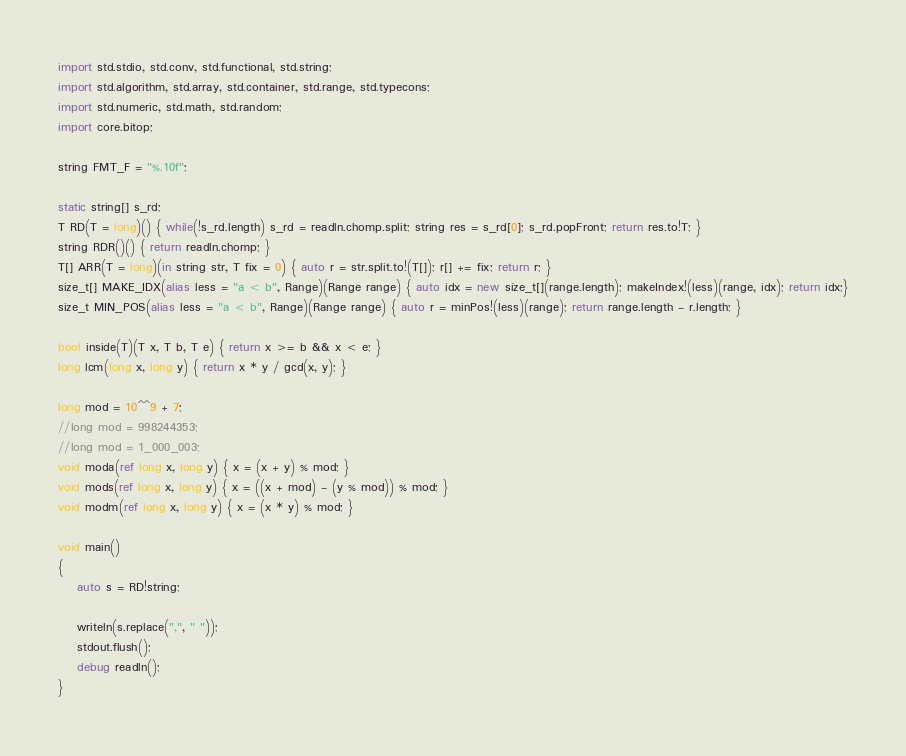<code> <loc_0><loc_0><loc_500><loc_500><_D_>import std.stdio, std.conv, std.functional, std.string;
import std.algorithm, std.array, std.container, std.range, std.typecons;
import std.numeric, std.math, std.random;
import core.bitop;

string FMT_F = "%.10f";

static string[] s_rd;
T RD(T = long)() { while(!s_rd.length) s_rd = readln.chomp.split; string res = s_rd[0]; s_rd.popFront; return res.to!T; }
string RDR()() { return readln.chomp; }
T[] ARR(T = long)(in string str, T fix = 0) { auto r = str.split.to!(T[]); r[] += fix; return r; }
size_t[] MAKE_IDX(alias less = "a < b", Range)(Range range) { auto idx = new size_t[](range.length); makeIndex!(less)(range, idx); return idx;}
size_t MIN_POS(alias less = "a < b", Range)(Range range) { auto r = minPos!(less)(range); return range.length - r.length; }

bool inside(T)(T x, T b, T e) { return x >= b && x < e; }
long lcm(long x, long y) { return x * y / gcd(x, y); }

long mod = 10^^9 + 7;
//long mod = 998244353;
//long mod = 1_000_003;
void moda(ref long x, long y) { x = (x + y) % mod; }
void mods(ref long x, long y) { x = ((x + mod) - (y % mod)) % mod; }
void modm(ref long x, long y) { x = (x * y) % mod; }

void main()
{
	auto s = RD!string;

	writeln(s.replace(",", " "));
	stdout.flush();
	debug readln();
}</code> 